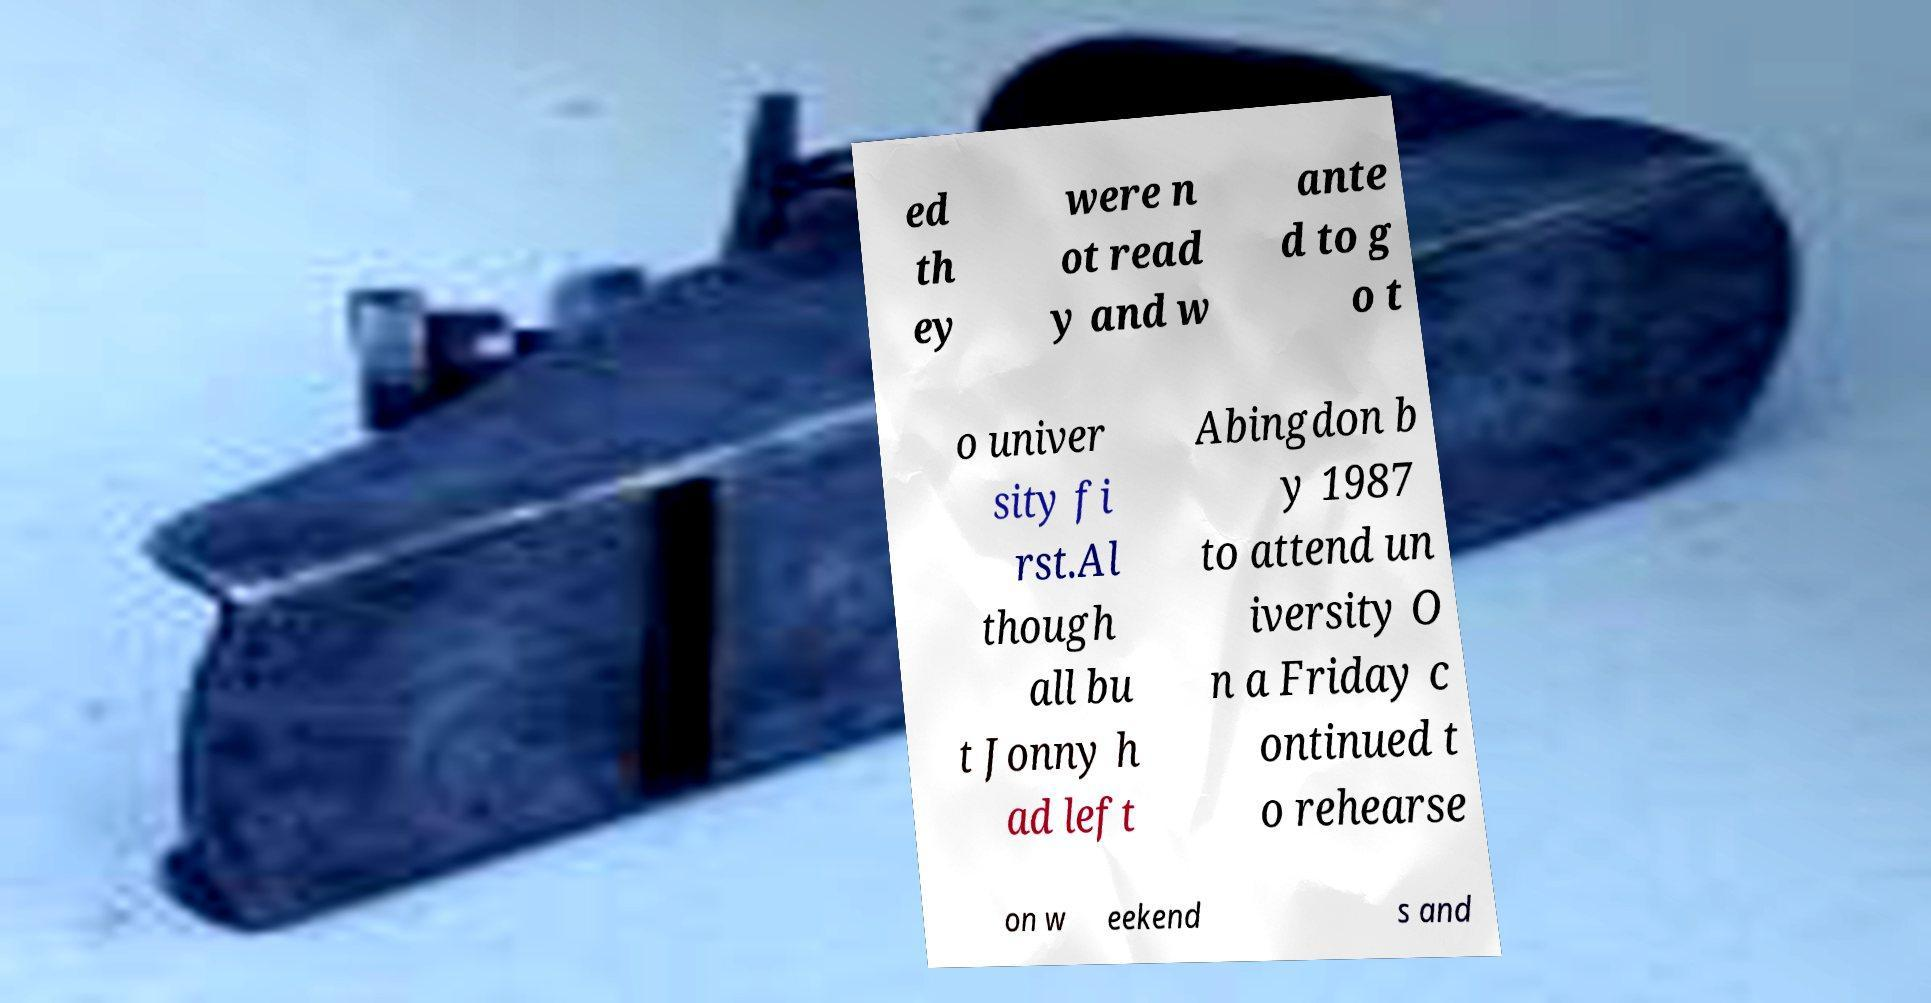I need the written content from this picture converted into text. Can you do that? ed th ey were n ot read y and w ante d to g o t o univer sity fi rst.Al though all bu t Jonny h ad left Abingdon b y 1987 to attend un iversity O n a Friday c ontinued t o rehearse on w eekend s and 